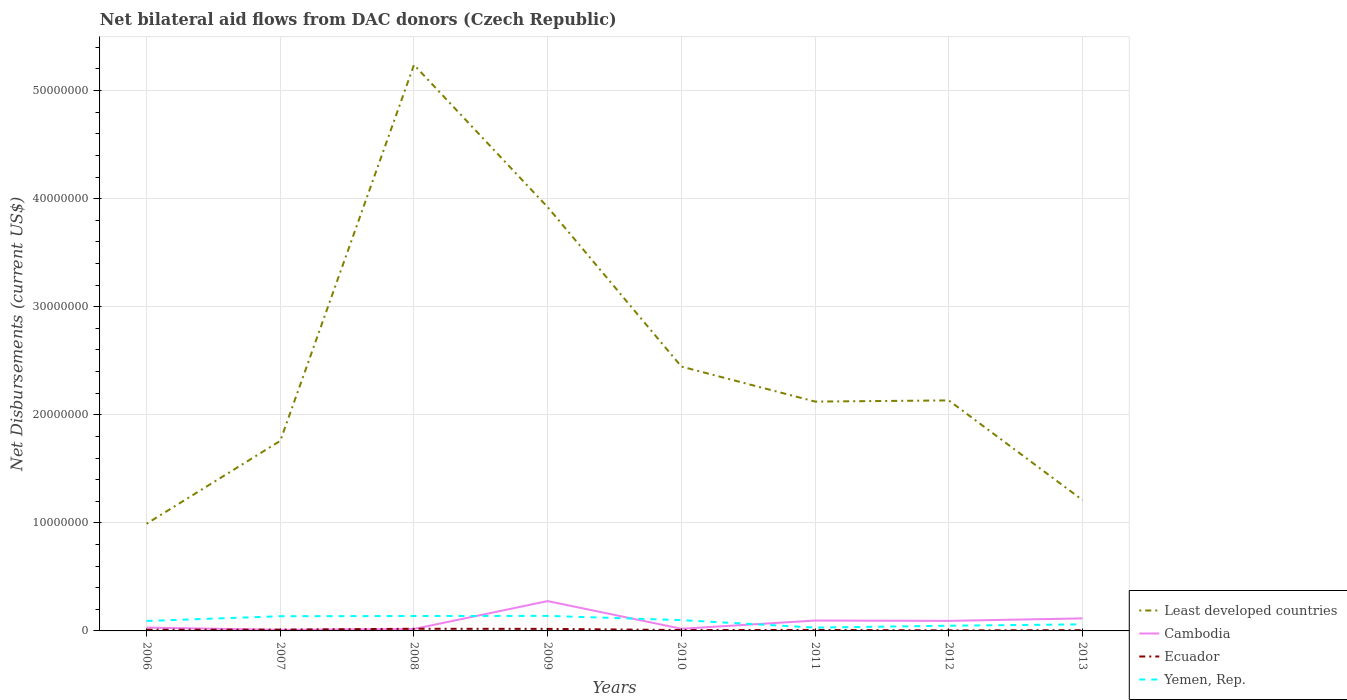How many different coloured lines are there?
Provide a short and direct response. 4. Does the line corresponding to Least developed countries intersect with the line corresponding to Yemen, Rep.?
Provide a short and direct response. No. Across all years, what is the maximum net bilateral aid flows in Ecuador?
Offer a terse response. 5.00e+04. In which year was the net bilateral aid flows in Cambodia maximum?
Offer a terse response. 2007. What is the total net bilateral aid flows in Ecuador in the graph?
Make the answer very short. 4.00e+04. What is the difference between the highest and the second highest net bilateral aid flows in Cambodia?
Make the answer very short. 2.66e+06. How many years are there in the graph?
Keep it short and to the point. 8. Are the values on the major ticks of Y-axis written in scientific E-notation?
Offer a very short reply. No. Does the graph contain any zero values?
Offer a very short reply. No. Does the graph contain grids?
Your response must be concise. Yes. How many legend labels are there?
Make the answer very short. 4. What is the title of the graph?
Ensure brevity in your answer.  Net bilateral aid flows from DAC donors (Czech Republic). What is the label or title of the X-axis?
Keep it short and to the point. Years. What is the label or title of the Y-axis?
Provide a succinct answer. Net Disbursements (current US$). What is the Net Disbursements (current US$) of Least developed countries in 2006?
Ensure brevity in your answer.  9.92e+06. What is the Net Disbursements (current US$) of Cambodia in 2006?
Ensure brevity in your answer.  3.10e+05. What is the Net Disbursements (current US$) of Yemen, Rep. in 2006?
Ensure brevity in your answer.  9.20e+05. What is the Net Disbursements (current US$) of Least developed countries in 2007?
Give a very brief answer. 1.76e+07. What is the Net Disbursements (current US$) of Cambodia in 2007?
Ensure brevity in your answer.  1.00e+05. What is the Net Disbursements (current US$) of Ecuador in 2007?
Provide a short and direct response. 1.20e+05. What is the Net Disbursements (current US$) of Yemen, Rep. in 2007?
Provide a succinct answer. 1.36e+06. What is the Net Disbursements (current US$) in Least developed countries in 2008?
Provide a succinct answer. 5.24e+07. What is the Net Disbursements (current US$) of Cambodia in 2008?
Offer a very short reply. 1.80e+05. What is the Net Disbursements (current US$) in Ecuador in 2008?
Offer a terse response. 2.00e+05. What is the Net Disbursements (current US$) of Yemen, Rep. in 2008?
Your response must be concise. 1.38e+06. What is the Net Disbursements (current US$) in Least developed countries in 2009?
Your answer should be compact. 3.92e+07. What is the Net Disbursements (current US$) of Cambodia in 2009?
Give a very brief answer. 2.76e+06. What is the Net Disbursements (current US$) of Ecuador in 2009?
Ensure brevity in your answer.  1.90e+05. What is the Net Disbursements (current US$) in Yemen, Rep. in 2009?
Give a very brief answer. 1.39e+06. What is the Net Disbursements (current US$) of Least developed countries in 2010?
Ensure brevity in your answer.  2.45e+07. What is the Net Disbursements (current US$) of Cambodia in 2010?
Your response must be concise. 2.00e+05. What is the Net Disbursements (current US$) of Ecuador in 2010?
Your response must be concise. 8.00e+04. What is the Net Disbursements (current US$) in Yemen, Rep. in 2010?
Provide a short and direct response. 1.00e+06. What is the Net Disbursements (current US$) of Least developed countries in 2011?
Your answer should be compact. 2.12e+07. What is the Net Disbursements (current US$) of Cambodia in 2011?
Your answer should be compact. 9.60e+05. What is the Net Disbursements (current US$) of Ecuador in 2011?
Provide a succinct answer. 9.00e+04. What is the Net Disbursements (current US$) in Yemen, Rep. in 2011?
Give a very brief answer. 3.10e+05. What is the Net Disbursements (current US$) in Least developed countries in 2012?
Keep it short and to the point. 2.13e+07. What is the Net Disbursements (current US$) of Cambodia in 2012?
Your answer should be very brief. 9.30e+05. What is the Net Disbursements (current US$) in Least developed countries in 2013?
Provide a short and direct response. 1.21e+07. What is the Net Disbursements (current US$) of Cambodia in 2013?
Ensure brevity in your answer.  1.16e+06. Across all years, what is the maximum Net Disbursements (current US$) in Least developed countries?
Keep it short and to the point. 5.24e+07. Across all years, what is the maximum Net Disbursements (current US$) in Cambodia?
Make the answer very short. 2.76e+06. Across all years, what is the maximum Net Disbursements (current US$) in Ecuador?
Make the answer very short. 2.00e+05. Across all years, what is the maximum Net Disbursements (current US$) in Yemen, Rep.?
Give a very brief answer. 1.39e+06. Across all years, what is the minimum Net Disbursements (current US$) in Least developed countries?
Offer a very short reply. 9.92e+06. Across all years, what is the minimum Net Disbursements (current US$) of Ecuador?
Offer a terse response. 5.00e+04. Across all years, what is the minimum Net Disbursements (current US$) of Yemen, Rep.?
Your answer should be very brief. 3.10e+05. What is the total Net Disbursements (current US$) of Least developed countries in the graph?
Your response must be concise. 1.98e+08. What is the total Net Disbursements (current US$) in Cambodia in the graph?
Your answer should be compact. 6.60e+06. What is the total Net Disbursements (current US$) in Ecuador in the graph?
Give a very brief answer. 9.10e+05. What is the total Net Disbursements (current US$) of Yemen, Rep. in the graph?
Provide a short and direct response. 7.45e+06. What is the difference between the Net Disbursements (current US$) in Least developed countries in 2006 and that in 2007?
Provide a short and direct response. -7.67e+06. What is the difference between the Net Disbursements (current US$) in Yemen, Rep. in 2006 and that in 2007?
Offer a very short reply. -4.40e+05. What is the difference between the Net Disbursements (current US$) in Least developed countries in 2006 and that in 2008?
Keep it short and to the point. -4.25e+07. What is the difference between the Net Disbursements (current US$) of Ecuador in 2006 and that in 2008?
Your answer should be very brief. -9.00e+04. What is the difference between the Net Disbursements (current US$) in Yemen, Rep. in 2006 and that in 2008?
Your answer should be very brief. -4.60e+05. What is the difference between the Net Disbursements (current US$) of Least developed countries in 2006 and that in 2009?
Ensure brevity in your answer.  -2.93e+07. What is the difference between the Net Disbursements (current US$) of Cambodia in 2006 and that in 2009?
Offer a terse response. -2.45e+06. What is the difference between the Net Disbursements (current US$) in Ecuador in 2006 and that in 2009?
Keep it short and to the point. -8.00e+04. What is the difference between the Net Disbursements (current US$) of Yemen, Rep. in 2006 and that in 2009?
Ensure brevity in your answer.  -4.70e+05. What is the difference between the Net Disbursements (current US$) of Least developed countries in 2006 and that in 2010?
Keep it short and to the point. -1.45e+07. What is the difference between the Net Disbursements (current US$) of Ecuador in 2006 and that in 2010?
Offer a very short reply. 3.00e+04. What is the difference between the Net Disbursements (current US$) in Yemen, Rep. in 2006 and that in 2010?
Make the answer very short. -8.00e+04. What is the difference between the Net Disbursements (current US$) of Least developed countries in 2006 and that in 2011?
Your response must be concise. -1.13e+07. What is the difference between the Net Disbursements (current US$) in Cambodia in 2006 and that in 2011?
Give a very brief answer. -6.50e+05. What is the difference between the Net Disbursements (current US$) of Ecuador in 2006 and that in 2011?
Your response must be concise. 2.00e+04. What is the difference between the Net Disbursements (current US$) in Yemen, Rep. in 2006 and that in 2011?
Offer a very short reply. 6.10e+05. What is the difference between the Net Disbursements (current US$) of Least developed countries in 2006 and that in 2012?
Your answer should be compact. -1.14e+07. What is the difference between the Net Disbursements (current US$) in Cambodia in 2006 and that in 2012?
Provide a succinct answer. -6.20e+05. What is the difference between the Net Disbursements (current US$) in Least developed countries in 2006 and that in 2013?
Provide a succinct answer. -2.19e+06. What is the difference between the Net Disbursements (current US$) in Cambodia in 2006 and that in 2013?
Make the answer very short. -8.50e+05. What is the difference between the Net Disbursements (current US$) in Ecuador in 2006 and that in 2013?
Ensure brevity in your answer.  4.00e+04. What is the difference between the Net Disbursements (current US$) of Least developed countries in 2007 and that in 2008?
Your response must be concise. -3.48e+07. What is the difference between the Net Disbursements (current US$) of Ecuador in 2007 and that in 2008?
Keep it short and to the point. -8.00e+04. What is the difference between the Net Disbursements (current US$) of Yemen, Rep. in 2007 and that in 2008?
Keep it short and to the point. -2.00e+04. What is the difference between the Net Disbursements (current US$) of Least developed countries in 2007 and that in 2009?
Your answer should be very brief. -2.16e+07. What is the difference between the Net Disbursements (current US$) of Cambodia in 2007 and that in 2009?
Your answer should be very brief. -2.66e+06. What is the difference between the Net Disbursements (current US$) of Yemen, Rep. in 2007 and that in 2009?
Offer a very short reply. -3.00e+04. What is the difference between the Net Disbursements (current US$) of Least developed countries in 2007 and that in 2010?
Make the answer very short. -6.87e+06. What is the difference between the Net Disbursements (current US$) in Cambodia in 2007 and that in 2010?
Your answer should be very brief. -1.00e+05. What is the difference between the Net Disbursements (current US$) in Yemen, Rep. in 2007 and that in 2010?
Keep it short and to the point. 3.60e+05. What is the difference between the Net Disbursements (current US$) in Least developed countries in 2007 and that in 2011?
Provide a succinct answer. -3.63e+06. What is the difference between the Net Disbursements (current US$) of Cambodia in 2007 and that in 2011?
Your answer should be compact. -8.60e+05. What is the difference between the Net Disbursements (current US$) in Yemen, Rep. in 2007 and that in 2011?
Offer a very short reply. 1.05e+06. What is the difference between the Net Disbursements (current US$) of Least developed countries in 2007 and that in 2012?
Offer a very short reply. -3.74e+06. What is the difference between the Net Disbursements (current US$) of Cambodia in 2007 and that in 2012?
Make the answer very short. -8.30e+05. What is the difference between the Net Disbursements (current US$) in Yemen, Rep. in 2007 and that in 2012?
Offer a terse response. 8.80e+05. What is the difference between the Net Disbursements (current US$) in Least developed countries in 2007 and that in 2013?
Offer a very short reply. 5.48e+06. What is the difference between the Net Disbursements (current US$) of Cambodia in 2007 and that in 2013?
Provide a succinct answer. -1.06e+06. What is the difference between the Net Disbursements (current US$) in Yemen, Rep. in 2007 and that in 2013?
Give a very brief answer. 7.50e+05. What is the difference between the Net Disbursements (current US$) of Least developed countries in 2008 and that in 2009?
Your response must be concise. 1.32e+07. What is the difference between the Net Disbursements (current US$) in Cambodia in 2008 and that in 2009?
Give a very brief answer. -2.58e+06. What is the difference between the Net Disbursements (current US$) in Ecuador in 2008 and that in 2009?
Ensure brevity in your answer.  10000. What is the difference between the Net Disbursements (current US$) of Yemen, Rep. in 2008 and that in 2009?
Keep it short and to the point. -10000. What is the difference between the Net Disbursements (current US$) of Least developed countries in 2008 and that in 2010?
Your answer should be compact. 2.79e+07. What is the difference between the Net Disbursements (current US$) of Ecuador in 2008 and that in 2010?
Your answer should be very brief. 1.20e+05. What is the difference between the Net Disbursements (current US$) of Yemen, Rep. in 2008 and that in 2010?
Offer a very short reply. 3.80e+05. What is the difference between the Net Disbursements (current US$) in Least developed countries in 2008 and that in 2011?
Offer a very short reply. 3.12e+07. What is the difference between the Net Disbursements (current US$) of Cambodia in 2008 and that in 2011?
Your response must be concise. -7.80e+05. What is the difference between the Net Disbursements (current US$) in Yemen, Rep. in 2008 and that in 2011?
Keep it short and to the point. 1.07e+06. What is the difference between the Net Disbursements (current US$) of Least developed countries in 2008 and that in 2012?
Offer a terse response. 3.10e+07. What is the difference between the Net Disbursements (current US$) of Cambodia in 2008 and that in 2012?
Provide a succinct answer. -7.50e+05. What is the difference between the Net Disbursements (current US$) of Ecuador in 2008 and that in 2012?
Offer a terse response. 1.50e+05. What is the difference between the Net Disbursements (current US$) in Least developed countries in 2008 and that in 2013?
Your answer should be very brief. 4.03e+07. What is the difference between the Net Disbursements (current US$) in Cambodia in 2008 and that in 2013?
Your answer should be compact. -9.80e+05. What is the difference between the Net Disbursements (current US$) in Ecuador in 2008 and that in 2013?
Make the answer very short. 1.30e+05. What is the difference between the Net Disbursements (current US$) in Yemen, Rep. in 2008 and that in 2013?
Offer a terse response. 7.70e+05. What is the difference between the Net Disbursements (current US$) of Least developed countries in 2009 and that in 2010?
Your answer should be very brief. 1.48e+07. What is the difference between the Net Disbursements (current US$) of Cambodia in 2009 and that in 2010?
Offer a terse response. 2.56e+06. What is the difference between the Net Disbursements (current US$) in Ecuador in 2009 and that in 2010?
Your response must be concise. 1.10e+05. What is the difference between the Net Disbursements (current US$) in Least developed countries in 2009 and that in 2011?
Offer a terse response. 1.80e+07. What is the difference between the Net Disbursements (current US$) of Cambodia in 2009 and that in 2011?
Offer a terse response. 1.80e+06. What is the difference between the Net Disbursements (current US$) of Yemen, Rep. in 2009 and that in 2011?
Your answer should be very brief. 1.08e+06. What is the difference between the Net Disbursements (current US$) in Least developed countries in 2009 and that in 2012?
Offer a terse response. 1.79e+07. What is the difference between the Net Disbursements (current US$) in Cambodia in 2009 and that in 2012?
Your answer should be very brief. 1.83e+06. What is the difference between the Net Disbursements (current US$) in Yemen, Rep. in 2009 and that in 2012?
Offer a very short reply. 9.10e+05. What is the difference between the Net Disbursements (current US$) in Least developed countries in 2009 and that in 2013?
Offer a terse response. 2.71e+07. What is the difference between the Net Disbursements (current US$) of Cambodia in 2009 and that in 2013?
Your answer should be very brief. 1.60e+06. What is the difference between the Net Disbursements (current US$) of Yemen, Rep. in 2009 and that in 2013?
Provide a succinct answer. 7.80e+05. What is the difference between the Net Disbursements (current US$) of Least developed countries in 2010 and that in 2011?
Offer a terse response. 3.24e+06. What is the difference between the Net Disbursements (current US$) of Cambodia in 2010 and that in 2011?
Make the answer very short. -7.60e+05. What is the difference between the Net Disbursements (current US$) in Yemen, Rep. in 2010 and that in 2011?
Your answer should be very brief. 6.90e+05. What is the difference between the Net Disbursements (current US$) in Least developed countries in 2010 and that in 2012?
Ensure brevity in your answer.  3.13e+06. What is the difference between the Net Disbursements (current US$) in Cambodia in 2010 and that in 2012?
Provide a short and direct response. -7.30e+05. What is the difference between the Net Disbursements (current US$) of Yemen, Rep. in 2010 and that in 2012?
Provide a short and direct response. 5.20e+05. What is the difference between the Net Disbursements (current US$) in Least developed countries in 2010 and that in 2013?
Give a very brief answer. 1.24e+07. What is the difference between the Net Disbursements (current US$) of Cambodia in 2010 and that in 2013?
Make the answer very short. -9.60e+05. What is the difference between the Net Disbursements (current US$) of Ecuador in 2010 and that in 2013?
Your answer should be very brief. 10000. What is the difference between the Net Disbursements (current US$) of Yemen, Rep. in 2010 and that in 2013?
Ensure brevity in your answer.  3.90e+05. What is the difference between the Net Disbursements (current US$) in Ecuador in 2011 and that in 2012?
Give a very brief answer. 4.00e+04. What is the difference between the Net Disbursements (current US$) in Least developed countries in 2011 and that in 2013?
Offer a very short reply. 9.11e+06. What is the difference between the Net Disbursements (current US$) of Ecuador in 2011 and that in 2013?
Make the answer very short. 2.00e+04. What is the difference between the Net Disbursements (current US$) in Least developed countries in 2012 and that in 2013?
Provide a short and direct response. 9.22e+06. What is the difference between the Net Disbursements (current US$) of Cambodia in 2012 and that in 2013?
Your answer should be very brief. -2.30e+05. What is the difference between the Net Disbursements (current US$) of Least developed countries in 2006 and the Net Disbursements (current US$) of Cambodia in 2007?
Your response must be concise. 9.82e+06. What is the difference between the Net Disbursements (current US$) of Least developed countries in 2006 and the Net Disbursements (current US$) of Ecuador in 2007?
Your answer should be very brief. 9.80e+06. What is the difference between the Net Disbursements (current US$) in Least developed countries in 2006 and the Net Disbursements (current US$) in Yemen, Rep. in 2007?
Make the answer very short. 8.56e+06. What is the difference between the Net Disbursements (current US$) in Cambodia in 2006 and the Net Disbursements (current US$) in Yemen, Rep. in 2007?
Keep it short and to the point. -1.05e+06. What is the difference between the Net Disbursements (current US$) of Ecuador in 2006 and the Net Disbursements (current US$) of Yemen, Rep. in 2007?
Ensure brevity in your answer.  -1.25e+06. What is the difference between the Net Disbursements (current US$) in Least developed countries in 2006 and the Net Disbursements (current US$) in Cambodia in 2008?
Make the answer very short. 9.74e+06. What is the difference between the Net Disbursements (current US$) of Least developed countries in 2006 and the Net Disbursements (current US$) of Ecuador in 2008?
Ensure brevity in your answer.  9.72e+06. What is the difference between the Net Disbursements (current US$) of Least developed countries in 2006 and the Net Disbursements (current US$) of Yemen, Rep. in 2008?
Ensure brevity in your answer.  8.54e+06. What is the difference between the Net Disbursements (current US$) in Cambodia in 2006 and the Net Disbursements (current US$) in Yemen, Rep. in 2008?
Ensure brevity in your answer.  -1.07e+06. What is the difference between the Net Disbursements (current US$) in Ecuador in 2006 and the Net Disbursements (current US$) in Yemen, Rep. in 2008?
Offer a terse response. -1.27e+06. What is the difference between the Net Disbursements (current US$) in Least developed countries in 2006 and the Net Disbursements (current US$) in Cambodia in 2009?
Offer a terse response. 7.16e+06. What is the difference between the Net Disbursements (current US$) of Least developed countries in 2006 and the Net Disbursements (current US$) of Ecuador in 2009?
Your answer should be very brief. 9.73e+06. What is the difference between the Net Disbursements (current US$) in Least developed countries in 2006 and the Net Disbursements (current US$) in Yemen, Rep. in 2009?
Your response must be concise. 8.53e+06. What is the difference between the Net Disbursements (current US$) in Cambodia in 2006 and the Net Disbursements (current US$) in Ecuador in 2009?
Give a very brief answer. 1.20e+05. What is the difference between the Net Disbursements (current US$) of Cambodia in 2006 and the Net Disbursements (current US$) of Yemen, Rep. in 2009?
Offer a very short reply. -1.08e+06. What is the difference between the Net Disbursements (current US$) in Ecuador in 2006 and the Net Disbursements (current US$) in Yemen, Rep. in 2009?
Provide a short and direct response. -1.28e+06. What is the difference between the Net Disbursements (current US$) of Least developed countries in 2006 and the Net Disbursements (current US$) of Cambodia in 2010?
Provide a succinct answer. 9.72e+06. What is the difference between the Net Disbursements (current US$) in Least developed countries in 2006 and the Net Disbursements (current US$) in Ecuador in 2010?
Offer a terse response. 9.84e+06. What is the difference between the Net Disbursements (current US$) of Least developed countries in 2006 and the Net Disbursements (current US$) of Yemen, Rep. in 2010?
Your answer should be very brief. 8.92e+06. What is the difference between the Net Disbursements (current US$) in Cambodia in 2006 and the Net Disbursements (current US$) in Ecuador in 2010?
Your answer should be compact. 2.30e+05. What is the difference between the Net Disbursements (current US$) in Cambodia in 2006 and the Net Disbursements (current US$) in Yemen, Rep. in 2010?
Your answer should be compact. -6.90e+05. What is the difference between the Net Disbursements (current US$) in Ecuador in 2006 and the Net Disbursements (current US$) in Yemen, Rep. in 2010?
Ensure brevity in your answer.  -8.90e+05. What is the difference between the Net Disbursements (current US$) in Least developed countries in 2006 and the Net Disbursements (current US$) in Cambodia in 2011?
Make the answer very short. 8.96e+06. What is the difference between the Net Disbursements (current US$) in Least developed countries in 2006 and the Net Disbursements (current US$) in Ecuador in 2011?
Provide a succinct answer. 9.83e+06. What is the difference between the Net Disbursements (current US$) in Least developed countries in 2006 and the Net Disbursements (current US$) in Yemen, Rep. in 2011?
Your response must be concise. 9.61e+06. What is the difference between the Net Disbursements (current US$) of Cambodia in 2006 and the Net Disbursements (current US$) of Yemen, Rep. in 2011?
Your response must be concise. 0. What is the difference between the Net Disbursements (current US$) of Least developed countries in 2006 and the Net Disbursements (current US$) of Cambodia in 2012?
Offer a very short reply. 8.99e+06. What is the difference between the Net Disbursements (current US$) of Least developed countries in 2006 and the Net Disbursements (current US$) of Ecuador in 2012?
Give a very brief answer. 9.87e+06. What is the difference between the Net Disbursements (current US$) of Least developed countries in 2006 and the Net Disbursements (current US$) of Yemen, Rep. in 2012?
Ensure brevity in your answer.  9.44e+06. What is the difference between the Net Disbursements (current US$) of Cambodia in 2006 and the Net Disbursements (current US$) of Yemen, Rep. in 2012?
Your answer should be very brief. -1.70e+05. What is the difference between the Net Disbursements (current US$) of Ecuador in 2006 and the Net Disbursements (current US$) of Yemen, Rep. in 2012?
Your answer should be compact. -3.70e+05. What is the difference between the Net Disbursements (current US$) in Least developed countries in 2006 and the Net Disbursements (current US$) in Cambodia in 2013?
Provide a succinct answer. 8.76e+06. What is the difference between the Net Disbursements (current US$) in Least developed countries in 2006 and the Net Disbursements (current US$) in Ecuador in 2013?
Keep it short and to the point. 9.85e+06. What is the difference between the Net Disbursements (current US$) of Least developed countries in 2006 and the Net Disbursements (current US$) of Yemen, Rep. in 2013?
Offer a very short reply. 9.31e+06. What is the difference between the Net Disbursements (current US$) in Cambodia in 2006 and the Net Disbursements (current US$) in Ecuador in 2013?
Provide a short and direct response. 2.40e+05. What is the difference between the Net Disbursements (current US$) of Ecuador in 2006 and the Net Disbursements (current US$) of Yemen, Rep. in 2013?
Offer a terse response. -5.00e+05. What is the difference between the Net Disbursements (current US$) in Least developed countries in 2007 and the Net Disbursements (current US$) in Cambodia in 2008?
Provide a succinct answer. 1.74e+07. What is the difference between the Net Disbursements (current US$) of Least developed countries in 2007 and the Net Disbursements (current US$) of Ecuador in 2008?
Ensure brevity in your answer.  1.74e+07. What is the difference between the Net Disbursements (current US$) in Least developed countries in 2007 and the Net Disbursements (current US$) in Yemen, Rep. in 2008?
Your response must be concise. 1.62e+07. What is the difference between the Net Disbursements (current US$) of Cambodia in 2007 and the Net Disbursements (current US$) of Yemen, Rep. in 2008?
Your answer should be compact. -1.28e+06. What is the difference between the Net Disbursements (current US$) in Ecuador in 2007 and the Net Disbursements (current US$) in Yemen, Rep. in 2008?
Offer a terse response. -1.26e+06. What is the difference between the Net Disbursements (current US$) of Least developed countries in 2007 and the Net Disbursements (current US$) of Cambodia in 2009?
Provide a succinct answer. 1.48e+07. What is the difference between the Net Disbursements (current US$) of Least developed countries in 2007 and the Net Disbursements (current US$) of Ecuador in 2009?
Keep it short and to the point. 1.74e+07. What is the difference between the Net Disbursements (current US$) of Least developed countries in 2007 and the Net Disbursements (current US$) of Yemen, Rep. in 2009?
Your answer should be very brief. 1.62e+07. What is the difference between the Net Disbursements (current US$) of Cambodia in 2007 and the Net Disbursements (current US$) of Yemen, Rep. in 2009?
Offer a terse response. -1.29e+06. What is the difference between the Net Disbursements (current US$) of Ecuador in 2007 and the Net Disbursements (current US$) of Yemen, Rep. in 2009?
Offer a very short reply. -1.27e+06. What is the difference between the Net Disbursements (current US$) of Least developed countries in 2007 and the Net Disbursements (current US$) of Cambodia in 2010?
Offer a very short reply. 1.74e+07. What is the difference between the Net Disbursements (current US$) of Least developed countries in 2007 and the Net Disbursements (current US$) of Ecuador in 2010?
Your response must be concise. 1.75e+07. What is the difference between the Net Disbursements (current US$) in Least developed countries in 2007 and the Net Disbursements (current US$) in Yemen, Rep. in 2010?
Give a very brief answer. 1.66e+07. What is the difference between the Net Disbursements (current US$) of Cambodia in 2007 and the Net Disbursements (current US$) of Ecuador in 2010?
Keep it short and to the point. 2.00e+04. What is the difference between the Net Disbursements (current US$) in Cambodia in 2007 and the Net Disbursements (current US$) in Yemen, Rep. in 2010?
Ensure brevity in your answer.  -9.00e+05. What is the difference between the Net Disbursements (current US$) in Ecuador in 2007 and the Net Disbursements (current US$) in Yemen, Rep. in 2010?
Your answer should be compact. -8.80e+05. What is the difference between the Net Disbursements (current US$) of Least developed countries in 2007 and the Net Disbursements (current US$) of Cambodia in 2011?
Your answer should be very brief. 1.66e+07. What is the difference between the Net Disbursements (current US$) in Least developed countries in 2007 and the Net Disbursements (current US$) in Ecuador in 2011?
Your answer should be very brief. 1.75e+07. What is the difference between the Net Disbursements (current US$) of Least developed countries in 2007 and the Net Disbursements (current US$) of Yemen, Rep. in 2011?
Your response must be concise. 1.73e+07. What is the difference between the Net Disbursements (current US$) in Cambodia in 2007 and the Net Disbursements (current US$) in Ecuador in 2011?
Offer a very short reply. 10000. What is the difference between the Net Disbursements (current US$) of Ecuador in 2007 and the Net Disbursements (current US$) of Yemen, Rep. in 2011?
Offer a very short reply. -1.90e+05. What is the difference between the Net Disbursements (current US$) in Least developed countries in 2007 and the Net Disbursements (current US$) in Cambodia in 2012?
Ensure brevity in your answer.  1.67e+07. What is the difference between the Net Disbursements (current US$) of Least developed countries in 2007 and the Net Disbursements (current US$) of Ecuador in 2012?
Give a very brief answer. 1.75e+07. What is the difference between the Net Disbursements (current US$) in Least developed countries in 2007 and the Net Disbursements (current US$) in Yemen, Rep. in 2012?
Your answer should be very brief. 1.71e+07. What is the difference between the Net Disbursements (current US$) of Cambodia in 2007 and the Net Disbursements (current US$) of Yemen, Rep. in 2012?
Make the answer very short. -3.80e+05. What is the difference between the Net Disbursements (current US$) of Ecuador in 2007 and the Net Disbursements (current US$) of Yemen, Rep. in 2012?
Ensure brevity in your answer.  -3.60e+05. What is the difference between the Net Disbursements (current US$) in Least developed countries in 2007 and the Net Disbursements (current US$) in Cambodia in 2013?
Provide a succinct answer. 1.64e+07. What is the difference between the Net Disbursements (current US$) of Least developed countries in 2007 and the Net Disbursements (current US$) of Ecuador in 2013?
Give a very brief answer. 1.75e+07. What is the difference between the Net Disbursements (current US$) of Least developed countries in 2007 and the Net Disbursements (current US$) of Yemen, Rep. in 2013?
Provide a short and direct response. 1.70e+07. What is the difference between the Net Disbursements (current US$) of Cambodia in 2007 and the Net Disbursements (current US$) of Yemen, Rep. in 2013?
Your response must be concise. -5.10e+05. What is the difference between the Net Disbursements (current US$) in Ecuador in 2007 and the Net Disbursements (current US$) in Yemen, Rep. in 2013?
Your answer should be very brief. -4.90e+05. What is the difference between the Net Disbursements (current US$) of Least developed countries in 2008 and the Net Disbursements (current US$) of Cambodia in 2009?
Your answer should be compact. 4.96e+07. What is the difference between the Net Disbursements (current US$) of Least developed countries in 2008 and the Net Disbursements (current US$) of Ecuador in 2009?
Your response must be concise. 5.22e+07. What is the difference between the Net Disbursements (current US$) of Least developed countries in 2008 and the Net Disbursements (current US$) of Yemen, Rep. in 2009?
Give a very brief answer. 5.10e+07. What is the difference between the Net Disbursements (current US$) in Cambodia in 2008 and the Net Disbursements (current US$) in Ecuador in 2009?
Provide a succinct answer. -10000. What is the difference between the Net Disbursements (current US$) in Cambodia in 2008 and the Net Disbursements (current US$) in Yemen, Rep. in 2009?
Your answer should be very brief. -1.21e+06. What is the difference between the Net Disbursements (current US$) in Ecuador in 2008 and the Net Disbursements (current US$) in Yemen, Rep. in 2009?
Your answer should be very brief. -1.19e+06. What is the difference between the Net Disbursements (current US$) of Least developed countries in 2008 and the Net Disbursements (current US$) of Cambodia in 2010?
Make the answer very short. 5.22e+07. What is the difference between the Net Disbursements (current US$) of Least developed countries in 2008 and the Net Disbursements (current US$) of Ecuador in 2010?
Give a very brief answer. 5.23e+07. What is the difference between the Net Disbursements (current US$) of Least developed countries in 2008 and the Net Disbursements (current US$) of Yemen, Rep. in 2010?
Keep it short and to the point. 5.14e+07. What is the difference between the Net Disbursements (current US$) in Cambodia in 2008 and the Net Disbursements (current US$) in Ecuador in 2010?
Give a very brief answer. 1.00e+05. What is the difference between the Net Disbursements (current US$) in Cambodia in 2008 and the Net Disbursements (current US$) in Yemen, Rep. in 2010?
Offer a terse response. -8.20e+05. What is the difference between the Net Disbursements (current US$) in Ecuador in 2008 and the Net Disbursements (current US$) in Yemen, Rep. in 2010?
Your response must be concise. -8.00e+05. What is the difference between the Net Disbursements (current US$) of Least developed countries in 2008 and the Net Disbursements (current US$) of Cambodia in 2011?
Provide a succinct answer. 5.14e+07. What is the difference between the Net Disbursements (current US$) of Least developed countries in 2008 and the Net Disbursements (current US$) of Ecuador in 2011?
Keep it short and to the point. 5.23e+07. What is the difference between the Net Disbursements (current US$) of Least developed countries in 2008 and the Net Disbursements (current US$) of Yemen, Rep. in 2011?
Make the answer very short. 5.21e+07. What is the difference between the Net Disbursements (current US$) of Least developed countries in 2008 and the Net Disbursements (current US$) of Cambodia in 2012?
Provide a succinct answer. 5.14e+07. What is the difference between the Net Disbursements (current US$) of Least developed countries in 2008 and the Net Disbursements (current US$) of Ecuador in 2012?
Ensure brevity in your answer.  5.23e+07. What is the difference between the Net Disbursements (current US$) of Least developed countries in 2008 and the Net Disbursements (current US$) of Yemen, Rep. in 2012?
Provide a short and direct response. 5.19e+07. What is the difference between the Net Disbursements (current US$) in Cambodia in 2008 and the Net Disbursements (current US$) in Ecuador in 2012?
Give a very brief answer. 1.30e+05. What is the difference between the Net Disbursements (current US$) of Cambodia in 2008 and the Net Disbursements (current US$) of Yemen, Rep. in 2012?
Give a very brief answer. -3.00e+05. What is the difference between the Net Disbursements (current US$) of Ecuador in 2008 and the Net Disbursements (current US$) of Yemen, Rep. in 2012?
Offer a terse response. -2.80e+05. What is the difference between the Net Disbursements (current US$) in Least developed countries in 2008 and the Net Disbursements (current US$) in Cambodia in 2013?
Your response must be concise. 5.12e+07. What is the difference between the Net Disbursements (current US$) in Least developed countries in 2008 and the Net Disbursements (current US$) in Ecuador in 2013?
Offer a very short reply. 5.23e+07. What is the difference between the Net Disbursements (current US$) in Least developed countries in 2008 and the Net Disbursements (current US$) in Yemen, Rep. in 2013?
Provide a succinct answer. 5.18e+07. What is the difference between the Net Disbursements (current US$) of Cambodia in 2008 and the Net Disbursements (current US$) of Yemen, Rep. in 2013?
Your response must be concise. -4.30e+05. What is the difference between the Net Disbursements (current US$) of Ecuador in 2008 and the Net Disbursements (current US$) of Yemen, Rep. in 2013?
Give a very brief answer. -4.10e+05. What is the difference between the Net Disbursements (current US$) of Least developed countries in 2009 and the Net Disbursements (current US$) of Cambodia in 2010?
Keep it short and to the point. 3.90e+07. What is the difference between the Net Disbursements (current US$) in Least developed countries in 2009 and the Net Disbursements (current US$) in Ecuador in 2010?
Your answer should be compact. 3.91e+07. What is the difference between the Net Disbursements (current US$) of Least developed countries in 2009 and the Net Disbursements (current US$) of Yemen, Rep. in 2010?
Make the answer very short. 3.82e+07. What is the difference between the Net Disbursements (current US$) of Cambodia in 2009 and the Net Disbursements (current US$) of Ecuador in 2010?
Your answer should be very brief. 2.68e+06. What is the difference between the Net Disbursements (current US$) of Cambodia in 2009 and the Net Disbursements (current US$) of Yemen, Rep. in 2010?
Give a very brief answer. 1.76e+06. What is the difference between the Net Disbursements (current US$) of Ecuador in 2009 and the Net Disbursements (current US$) of Yemen, Rep. in 2010?
Your answer should be compact. -8.10e+05. What is the difference between the Net Disbursements (current US$) of Least developed countries in 2009 and the Net Disbursements (current US$) of Cambodia in 2011?
Provide a succinct answer. 3.82e+07. What is the difference between the Net Disbursements (current US$) of Least developed countries in 2009 and the Net Disbursements (current US$) of Ecuador in 2011?
Offer a very short reply. 3.91e+07. What is the difference between the Net Disbursements (current US$) in Least developed countries in 2009 and the Net Disbursements (current US$) in Yemen, Rep. in 2011?
Provide a short and direct response. 3.89e+07. What is the difference between the Net Disbursements (current US$) of Cambodia in 2009 and the Net Disbursements (current US$) of Ecuador in 2011?
Your answer should be very brief. 2.67e+06. What is the difference between the Net Disbursements (current US$) of Cambodia in 2009 and the Net Disbursements (current US$) of Yemen, Rep. in 2011?
Your response must be concise. 2.45e+06. What is the difference between the Net Disbursements (current US$) in Ecuador in 2009 and the Net Disbursements (current US$) in Yemen, Rep. in 2011?
Your response must be concise. -1.20e+05. What is the difference between the Net Disbursements (current US$) of Least developed countries in 2009 and the Net Disbursements (current US$) of Cambodia in 2012?
Your answer should be compact. 3.83e+07. What is the difference between the Net Disbursements (current US$) in Least developed countries in 2009 and the Net Disbursements (current US$) in Ecuador in 2012?
Your answer should be very brief. 3.92e+07. What is the difference between the Net Disbursements (current US$) of Least developed countries in 2009 and the Net Disbursements (current US$) of Yemen, Rep. in 2012?
Your response must be concise. 3.87e+07. What is the difference between the Net Disbursements (current US$) in Cambodia in 2009 and the Net Disbursements (current US$) in Ecuador in 2012?
Offer a terse response. 2.71e+06. What is the difference between the Net Disbursements (current US$) in Cambodia in 2009 and the Net Disbursements (current US$) in Yemen, Rep. in 2012?
Keep it short and to the point. 2.28e+06. What is the difference between the Net Disbursements (current US$) in Least developed countries in 2009 and the Net Disbursements (current US$) in Cambodia in 2013?
Your answer should be compact. 3.80e+07. What is the difference between the Net Disbursements (current US$) of Least developed countries in 2009 and the Net Disbursements (current US$) of Ecuador in 2013?
Make the answer very short. 3.91e+07. What is the difference between the Net Disbursements (current US$) in Least developed countries in 2009 and the Net Disbursements (current US$) in Yemen, Rep. in 2013?
Keep it short and to the point. 3.86e+07. What is the difference between the Net Disbursements (current US$) of Cambodia in 2009 and the Net Disbursements (current US$) of Ecuador in 2013?
Provide a short and direct response. 2.69e+06. What is the difference between the Net Disbursements (current US$) in Cambodia in 2009 and the Net Disbursements (current US$) in Yemen, Rep. in 2013?
Give a very brief answer. 2.15e+06. What is the difference between the Net Disbursements (current US$) in Ecuador in 2009 and the Net Disbursements (current US$) in Yemen, Rep. in 2013?
Offer a very short reply. -4.20e+05. What is the difference between the Net Disbursements (current US$) in Least developed countries in 2010 and the Net Disbursements (current US$) in Cambodia in 2011?
Your answer should be compact. 2.35e+07. What is the difference between the Net Disbursements (current US$) in Least developed countries in 2010 and the Net Disbursements (current US$) in Ecuador in 2011?
Keep it short and to the point. 2.44e+07. What is the difference between the Net Disbursements (current US$) of Least developed countries in 2010 and the Net Disbursements (current US$) of Yemen, Rep. in 2011?
Your answer should be very brief. 2.42e+07. What is the difference between the Net Disbursements (current US$) in Cambodia in 2010 and the Net Disbursements (current US$) in Ecuador in 2011?
Provide a succinct answer. 1.10e+05. What is the difference between the Net Disbursements (current US$) of Cambodia in 2010 and the Net Disbursements (current US$) of Yemen, Rep. in 2011?
Provide a short and direct response. -1.10e+05. What is the difference between the Net Disbursements (current US$) in Ecuador in 2010 and the Net Disbursements (current US$) in Yemen, Rep. in 2011?
Keep it short and to the point. -2.30e+05. What is the difference between the Net Disbursements (current US$) in Least developed countries in 2010 and the Net Disbursements (current US$) in Cambodia in 2012?
Your response must be concise. 2.35e+07. What is the difference between the Net Disbursements (current US$) in Least developed countries in 2010 and the Net Disbursements (current US$) in Ecuador in 2012?
Offer a terse response. 2.44e+07. What is the difference between the Net Disbursements (current US$) of Least developed countries in 2010 and the Net Disbursements (current US$) of Yemen, Rep. in 2012?
Your answer should be very brief. 2.40e+07. What is the difference between the Net Disbursements (current US$) in Cambodia in 2010 and the Net Disbursements (current US$) in Yemen, Rep. in 2012?
Provide a short and direct response. -2.80e+05. What is the difference between the Net Disbursements (current US$) of Ecuador in 2010 and the Net Disbursements (current US$) of Yemen, Rep. in 2012?
Ensure brevity in your answer.  -4.00e+05. What is the difference between the Net Disbursements (current US$) in Least developed countries in 2010 and the Net Disbursements (current US$) in Cambodia in 2013?
Your answer should be very brief. 2.33e+07. What is the difference between the Net Disbursements (current US$) in Least developed countries in 2010 and the Net Disbursements (current US$) in Ecuador in 2013?
Your answer should be very brief. 2.44e+07. What is the difference between the Net Disbursements (current US$) of Least developed countries in 2010 and the Net Disbursements (current US$) of Yemen, Rep. in 2013?
Give a very brief answer. 2.38e+07. What is the difference between the Net Disbursements (current US$) of Cambodia in 2010 and the Net Disbursements (current US$) of Ecuador in 2013?
Keep it short and to the point. 1.30e+05. What is the difference between the Net Disbursements (current US$) of Cambodia in 2010 and the Net Disbursements (current US$) of Yemen, Rep. in 2013?
Give a very brief answer. -4.10e+05. What is the difference between the Net Disbursements (current US$) in Ecuador in 2010 and the Net Disbursements (current US$) in Yemen, Rep. in 2013?
Make the answer very short. -5.30e+05. What is the difference between the Net Disbursements (current US$) in Least developed countries in 2011 and the Net Disbursements (current US$) in Cambodia in 2012?
Ensure brevity in your answer.  2.03e+07. What is the difference between the Net Disbursements (current US$) in Least developed countries in 2011 and the Net Disbursements (current US$) in Ecuador in 2012?
Offer a very short reply. 2.12e+07. What is the difference between the Net Disbursements (current US$) of Least developed countries in 2011 and the Net Disbursements (current US$) of Yemen, Rep. in 2012?
Ensure brevity in your answer.  2.07e+07. What is the difference between the Net Disbursements (current US$) of Cambodia in 2011 and the Net Disbursements (current US$) of Ecuador in 2012?
Your response must be concise. 9.10e+05. What is the difference between the Net Disbursements (current US$) in Ecuador in 2011 and the Net Disbursements (current US$) in Yemen, Rep. in 2012?
Ensure brevity in your answer.  -3.90e+05. What is the difference between the Net Disbursements (current US$) of Least developed countries in 2011 and the Net Disbursements (current US$) of Cambodia in 2013?
Your answer should be compact. 2.01e+07. What is the difference between the Net Disbursements (current US$) of Least developed countries in 2011 and the Net Disbursements (current US$) of Ecuador in 2013?
Provide a succinct answer. 2.12e+07. What is the difference between the Net Disbursements (current US$) in Least developed countries in 2011 and the Net Disbursements (current US$) in Yemen, Rep. in 2013?
Your answer should be very brief. 2.06e+07. What is the difference between the Net Disbursements (current US$) in Cambodia in 2011 and the Net Disbursements (current US$) in Ecuador in 2013?
Your response must be concise. 8.90e+05. What is the difference between the Net Disbursements (current US$) of Ecuador in 2011 and the Net Disbursements (current US$) of Yemen, Rep. in 2013?
Your answer should be very brief. -5.20e+05. What is the difference between the Net Disbursements (current US$) in Least developed countries in 2012 and the Net Disbursements (current US$) in Cambodia in 2013?
Provide a succinct answer. 2.02e+07. What is the difference between the Net Disbursements (current US$) in Least developed countries in 2012 and the Net Disbursements (current US$) in Ecuador in 2013?
Offer a very short reply. 2.13e+07. What is the difference between the Net Disbursements (current US$) of Least developed countries in 2012 and the Net Disbursements (current US$) of Yemen, Rep. in 2013?
Your response must be concise. 2.07e+07. What is the difference between the Net Disbursements (current US$) of Cambodia in 2012 and the Net Disbursements (current US$) of Ecuador in 2013?
Offer a very short reply. 8.60e+05. What is the difference between the Net Disbursements (current US$) in Cambodia in 2012 and the Net Disbursements (current US$) in Yemen, Rep. in 2013?
Provide a short and direct response. 3.20e+05. What is the difference between the Net Disbursements (current US$) of Ecuador in 2012 and the Net Disbursements (current US$) of Yemen, Rep. in 2013?
Your answer should be very brief. -5.60e+05. What is the average Net Disbursements (current US$) of Least developed countries per year?
Give a very brief answer. 2.48e+07. What is the average Net Disbursements (current US$) in Cambodia per year?
Give a very brief answer. 8.25e+05. What is the average Net Disbursements (current US$) in Ecuador per year?
Offer a very short reply. 1.14e+05. What is the average Net Disbursements (current US$) in Yemen, Rep. per year?
Your answer should be compact. 9.31e+05. In the year 2006, what is the difference between the Net Disbursements (current US$) in Least developed countries and Net Disbursements (current US$) in Cambodia?
Your response must be concise. 9.61e+06. In the year 2006, what is the difference between the Net Disbursements (current US$) in Least developed countries and Net Disbursements (current US$) in Ecuador?
Offer a very short reply. 9.81e+06. In the year 2006, what is the difference between the Net Disbursements (current US$) in Least developed countries and Net Disbursements (current US$) in Yemen, Rep.?
Ensure brevity in your answer.  9.00e+06. In the year 2006, what is the difference between the Net Disbursements (current US$) of Cambodia and Net Disbursements (current US$) of Ecuador?
Your answer should be compact. 2.00e+05. In the year 2006, what is the difference between the Net Disbursements (current US$) of Cambodia and Net Disbursements (current US$) of Yemen, Rep.?
Your answer should be compact. -6.10e+05. In the year 2006, what is the difference between the Net Disbursements (current US$) in Ecuador and Net Disbursements (current US$) in Yemen, Rep.?
Your answer should be compact. -8.10e+05. In the year 2007, what is the difference between the Net Disbursements (current US$) in Least developed countries and Net Disbursements (current US$) in Cambodia?
Ensure brevity in your answer.  1.75e+07. In the year 2007, what is the difference between the Net Disbursements (current US$) in Least developed countries and Net Disbursements (current US$) in Ecuador?
Your response must be concise. 1.75e+07. In the year 2007, what is the difference between the Net Disbursements (current US$) in Least developed countries and Net Disbursements (current US$) in Yemen, Rep.?
Give a very brief answer. 1.62e+07. In the year 2007, what is the difference between the Net Disbursements (current US$) of Cambodia and Net Disbursements (current US$) of Yemen, Rep.?
Make the answer very short. -1.26e+06. In the year 2007, what is the difference between the Net Disbursements (current US$) of Ecuador and Net Disbursements (current US$) of Yemen, Rep.?
Provide a succinct answer. -1.24e+06. In the year 2008, what is the difference between the Net Disbursements (current US$) of Least developed countries and Net Disbursements (current US$) of Cambodia?
Provide a succinct answer. 5.22e+07. In the year 2008, what is the difference between the Net Disbursements (current US$) in Least developed countries and Net Disbursements (current US$) in Ecuador?
Provide a succinct answer. 5.22e+07. In the year 2008, what is the difference between the Net Disbursements (current US$) in Least developed countries and Net Disbursements (current US$) in Yemen, Rep.?
Offer a terse response. 5.10e+07. In the year 2008, what is the difference between the Net Disbursements (current US$) in Cambodia and Net Disbursements (current US$) in Ecuador?
Provide a short and direct response. -2.00e+04. In the year 2008, what is the difference between the Net Disbursements (current US$) of Cambodia and Net Disbursements (current US$) of Yemen, Rep.?
Keep it short and to the point. -1.20e+06. In the year 2008, what is the difference between the Net Disbursements (current US$) of Ecuador and Net Disbursements (current US$) of Yemen, Rep.?
Ensure brevity in your answer.  -1.18e+06. In the year 2009, what is the difference between the Net Disbursements (current US$) in Least developed countries and Net Disbursements (current US$) in Cambodia?
Offer a terse response. 3.64e+07. In the year 2009, what is the difference between the Net Disbursements (current US$) in Least developed countries and Net Disbursements (current US$) in Ecuador?
Your response must be concise. 3.90e+07. In the year 2009, what is the difference between the Net Disbursements (current US$) in Least developed countries and Net Disbursements (current US$) in Yemen, Rep.?
Provide a succinct answer. 3.78e+07. In the year 2009, what is the difference between the Net Disbursements (current US$) of Cambodia and Net Disbursements (current US$) of Ecuador?
Keep it short and to the point. 2.57e+06. In the year 2009, what is the difference between the Net Disbursements (current US$) in Cambodia and Net Disbursements (current US$) in Yemen, Rep.?
Provide a succinct answer. 1.37e+06. In the year 2009, what is the difference between the Net Disbursements (current US$) in Ecuador and Net Disbursements (current US$) in Yemen, Rep.?
Ensure brevity in your answer.  -1.20e+06. In the year 2010, what is the difference between the Net Disbursements (current US$) of Least developed countries and Net Disbursements (current US$) of Cambodia?
Offer a terse response. 2.43e+07. In the year 2010, what is the difference between the Net Disbursements (current US$) in Least developed countries and Net Disbursements (current US$) in Ecuador?
Provide a succinct answer. 2.44e+07. In the year 2010, what is the difference between the Net Disbursements (current US$) in Least developed countries and Net Disbursements (current US$) in Yemen, Rep.?
Ensure brevity in your answer.  2.35e+07. In the year 2010, what is the difference between the Net Disbursements (current US$) of Cambodia and Net Disbursements (current US$) of Yemen, Rep.?
Offer a very short reply. -8.00e+05. In the year 2010, what is the difference between the Net Disbursements (current US$) in Ecuador and Net Disbursements (current US$) in Yemen, Rep.?
Your response must be concise. -9.20e+05. In the year 2011, what is the difference between the Net Disbursements (current US$) in Least developed countries and Net Disbursements (current US$) in Cambodia?
Give a very brief answer. 2.03e+07. In the year 2011, what is the difference between the Net Disbursements (current US$) of Least developed countries and Net Disbursements (current US$) of Ecuador?
Your answer should be very brief. 2.11e+07. In the year 2011, what is the difference between the Net Disbursements (current US$) of Least developed countries and Net Disbursements (current US$) of Yemen, Rep.?
Provide a short and direct response. 2.09e+07. In the year 2011, what is the difference between the Net Disbursements (current US$) of Cambodia and Net Disbursements (current US$) of Ecuador?
Provide a succinct answer. 8.70e+05. In the year 2011, what is the difference between the Net Disbursements (current US$) in Cambodia and Net Disbursements (current US$) in Yemen, Rep.?
Provide a short and direct response. 6.50e+05. In the year 2011, what is the difference between the Net Disbursements (current US$) of Ecuador and Net Disbursements (current US$) of Yemen, Rep.?
Your answer should be very brief. -2.20e+05. In the year 2012, what is the difference between the Net Disbursements (current US$) of Least developed countries and Net Disbursements (current US$) of Cambodia?
Ensure brevity in your answer.  2.04e+07. In the year 2012, what is the difference between the Net Disbursements (current US$) of Least developed countries and Net Disbursements (current US$) of Ecuador?
Offer a terse response. 2.13e+07. In the year 2012, what is the difference between the Net Disbursements (current US$) in Least developed countries and Net Disbursements (current US$) in Yemen, Rep.?
Your answer should be compact. 2.08e+07. In the year 2012, what is the difference between the Net Disbursements (current US$) in Cambodia and Net Disbursements (current US$) in Ecuador?
Keep it short and to the point. 8.80e+05. In the year 2012, what is the difference between the Net Disbursements (current US$) of Cambodia and Net Disbursements (current US$) of Yemen, Rep.?
Your response must be concise. 4.50e+05. In the year 2012, what is the difference between the Net Disbursements (current US$) of Ecuador and Net Disbursements (current US$) of Yemen, Rep.?
Ensure brevity in your answer.  -4.30e+05. In the year 2013, what is the difference between the Net Disbursements (current US$) of Least developed countries and Net Disbursements (current US$) of Cambodia?
Offer a very short reply. 1.10e+07. In the year 2013, what is the difference between the Net Disbursements (current US$) in Least developed countries and Net Disbursements (current US$) in Ecuador?
Offer a very short reply. 1.20e+07. In the year 2013, what is the difference between the Net Disbursements (current US$) of Least developed countries and Net Disbursements (current US$) of Yemen, Rep.?
Keep it short and to the point. 1.15e+07. In the year 2013, what is the difference between the Net Disbursements (current US$) in Cambodia and Net Disbursements (current US$) in Ecuador?
Ensure brevity in your answer.  1.09e+06. In the year 2013, what is the difference between the Net Disbursements (current US$) of Ecuador and Net Disbursements (current US$) of Yemen, Rep.?
Offer a terse response. -5.40e+05. What is the ratio of the Net Disbursements (current US$) of Least developed countries in 2006 to that in 2007?
Your answer should be very brief. 0.56. What is the ratio of the Net Disbursements (current US$) in Yemen, Rep. in 2006 to that in 2007?
Make the answer very short. 0.68. What is the ratio of the Net Disbursements (current US$) of Least developed countries in 2006 to that in 2008?
Provide a short and direct response. 0.19. What is the ratio of the Net Disbursements (current US$) of Cambodia in 2006 to that in 2008?
Keep it short and to the point. 1.72. What is the ratio of the Net Disbursements (current US$) of Ecuador in 2006 to that in 2008?
Offer a very short reply. 0.55. What is the ratio of the Net Disbursements (current US$) of Yemen, Rep. in 2006 to that in 2008?
Provide a succinct answer. 0.67. What is the ratio of the Net Disbursements (current US$) of Least developed countries in 2006 to that in 2009?
Give a very brief answer. 0.25. What is the ratio of the Net Disbursements (current US$) in Cambodia in 2006 to that in 2009?
Provide a short and direct response. 0.11. What is the ratio of the Net Disbursements (current US$) of Ecuador in 2006 to that in 2009?
Your answer should be very brief. 0.58. What is the ratio of the Net Disbursements (current US$) of Yemen, Rep. in 2006 to that in 2009?
Ensure brevity in your answer.  0.66. What is the ratio of the Net Disbursements (current US$) of Least developed countries in 2006 to that in 2010?
Your answer should be compact. 0.41. What is the ratio of the Net Disbursements (current US$) of Cambodia in 2006 to that in 2010?
Offer a very short reply. 1.55. What is the ratio of the Net Disbursements (current US$) of Ecuador in 2006 to that in 2010?
Your answer should be very brief. 1.38. What is the ratio of the Net Disbursements (current US$) of Yemen, Rep. in 2006 to that in 2010?
Offer a very short reply. 0.92. What is the ratio of the Net Disbursements (current US$) in Least developed countries in 2006 to that in 2011?
Make the answer very short. 0.47. What is the ratio of the Net Disbursements (current US$) of Cambodia in 2006 to that in 2011?
Keep it short and to the point. 0.32. What is the ratio of the Net Disbursements (current US$) of Ecuador in 2006 to that in 2011?
Your answer should be compact. 1.22. What is the ratio of the Net Disbursements (current US$) in Yemen, Rep. in 2006 to that in 2011?
Provide a succinct answer. 2.97. What is the ratio of the Net Disbursements (current US$) in Least developed countries in 2006 to that in 2012?
Ensure brevity in your answer.  0.47. What is the ratio of the Net Disbursements (current US$) of Cambodia in 2006 to that in 2012?
Provide a short and direct response. 0.33. What is the ratio of the Net Disbursements (current US$) of Yemen, Rep. in 2006 to that in 2012?
Your answer should be compact. 1.92. What is the ratio of the Net Disbursements (current US$) in Least developed countries in 2006 to that in 2013?
Give a very brief answer. 0.82. What is the ratio of the Net Disbursements (current US$) of Cambodia in 2006 to that in 2013?
Provide a short and direct response. 0.27. What is the ratio of the Net Disbursements (current US$) of Ecuador in 2006 to that in 2013?
Provide a succinct answer. 1.57. What is the ratio of the Net Disbursements (current US$) in Yemen, Rep. in 2006 to that in 2013?
Offer a terse response. 1.51. What is the ratio of the Net Disbursements (current US$) in Least developed countries in 2007 to that in 2008?
Offer a very short reply. 0.34. What is the ratio of the Net Disbursements (current US$) of Cambodia in 2007 to that in 2008?
Your answer should be compact. 0.56. What is the ratio of the Net Disbursements (current US$) in Yemen, Rep. in 2007 to that in 2008?
Your response must be concise. 0.99. What is the ratio of the Net Disbursements (current US$) of Least developed countries in 2007 to that in 2009?
Give a very brief answer. 0.45. What is the ratio of the Net Disbursements (current US$) in Cambodia in 2007 to that in 2009?
Your response must be concise. 0.04. What is the ratio of the Net Disbursements (current US$) in Ecuador in 2007 to that in 2009?
Make the answer very short. 0.63. What is the ratio of the Net Disbursements (current US$) in Yemen, Rep. in 2007 to that in 2009?
Give a very brief answer. 0.98. What is the ratio of the Net Disbursements (current US$) in Least developed countries in 2007 to that in 2010?
Give a very brief answer. 0.72. What is the ratio of the Net Disbursements (current US$) of Cambodia in 2007 to that in 2010?
Your answer should be compact. 0.5. What is the ratio of the Net Disbursements (current US$) of Yemen, Rep. in 2007 to that in 2010?
Provide a short and direct response. 1.36. What is the ratio of the Net Disbursements (current US$) of Least developed countries in 2007 to that in 2011?
Offer a terse response. 0.83. What is the ratio of the Net Disbursements (current US$) in Cambodia in 2007 to that in 2011?
Make the answer very short. 0.1. What is the ratio of the Net Disbursements (current US$) in Yemen, Rep. in 2007 to that in 2011?
Your answer should be very brief. 4.39. What is the ratio of the Net Disbursements (current US$) in Least developed countries in 2007 to that in 2012?
Your answer should be very brief. 0.82. What is the ratio of the Net Disbursements (current US$) of Cambodia in 2007 to that in 2012?
Provide a short and direct response. 0.11. What is the ratio of the Net Disbursements (current US$) of Ecuador in 2007 to that in 2012?
Your answer should be compact. 2.4. What is the ratio of the Net Disbursements (current US$) of Yemen, Rep. in 2007 to that in 2012?
Your response must be concise. 2.83. What is the ratio of the Net Disbursements (current US$) in Least developed countries in 2007 to that in 2013?
Offer a terse response. 1.45. What is the ratio of the Net Disbursements (current US$) of Cambodia in 2007 to that in 2013?
Your answer should be very brief. 0.09. What is the ratio of the Net Disbursements (current US$) of Ecuador in 2007 to that in 2013?
Your answer should be very brief. 1.71. What is the ratio of the Net Disbursements (current US$) in Yemen, Rep. in 2007 to that in 2013?
Offer a very short reply. 2.23. What is the ratio of the Net Disbursements (current US$) of Least developed countries in 2008 to that in 2009?
Your response must be concise. 1.34. What is the ratio of the Net Disbursements (current US$) in Cambodia in 2008 to that in 2009?
Your answer should be very brief. 0.07. What is the ratio of the Net Disbursements (current US$) in Ecuador in 2008 to that in 2009?
Give a very brief answer. 1.05. What is the ratio of the Net Disbursements (current US$) in Yemen, Rep. in 2008 to that in 2009?
Your answer should be compact. 0.99. What is the ratio of the Net Disbursements (current US$) of Least developed countries in 2008 to that in 2010?
Your answer should be very brief. 2.14. What is the ratio of the Net Disbursements (current US$) in Yemen, Rep. in 2008 to that in 2010?
Offer a terse response. 1.38. What is the ratio of the Net Disbursements (current US$) of Least developed countries in 2008 to that in 2011?
Make the answer very short. 2.47. What is the ratio of the Net Disbursements (current US$) of Cambodia in 2008 to that in 2011?
Ensure brevity in your answer.  0.19. What is the ratio of the Net Disbursements (current US$) of Ecuador in 2008 to that in 2011?
Make the answer very short. 2.22. What is the ratio of the Net Disbursements (current US$) in Yemen, Rep. in 2008 to that in 2011?
Your answer should be compact. 4.45. What is the ratio of the Net Disbursements (current US$) of Least developed countries in 2008 to that in 2012?
Ensure brevity in your answer.  2.46. What is the ratio of the Net Disbursements (current US$) in Cambodia in 2008 to that in 2012?
Keep it short and to the point. 0.19. What is the ratio of the Net Disbursements (current US$) in Yemen, Rep. in 2008 to that in 2012?
Your answer should be compact. 2.88. What is the ratio of the Net Disbursements (current US$) of Least developed countries in 2008 to that in 2013?
Your answer should be very brief. 4.33. What is the ratio of the Net Disbursements (current US$) in Cambodia in 2008 to that in 2013?
Keep it short and to the point. 0.16. What is the ratio of the Net Disbursements (current US$) of Ecuador in 2008 to that in 2013?
Your answer should be compact. 2.86. What is the ratio of the Net Disbursements (current US$) in Yemen, Rep. in 2008 to that in 2013?
Offer a terse response. 2.26. What is the ratio of the Net Disbursements (current US$) in Least developed countries in 2009 to that in 2010?
Ensure brevity in your answer.  1.6. What is the ratio of the Net Disbursements (current US$) of Ecuador in 2009 to that in 2010?
Give a very brief answer. 2.38. What is the ratio of the Net Disbursements (current US$) of Yemen, Rep. in 2009 to that in 2010?
Provide a succinct answer. 1.39. What is the ratio of the Net Disbursements (current US$) in Least developed countries in 2009 to that in 2011?
Give a very brief answer. 1.85. What is the ratio of the Net Disbursements (current US$) in Cambodia in 2009 to that in 2011?
Ensure brevity in your answer.  2.88. What is the ratio of the Net Disbursements (current US$) of Ecuador in 2009 to that in 2011?
Keep it short and to the point. 2.11. What is the ratio of the Net Disbursements (current US$) in Yemen, Rep. in 2009 to that in 2011?
Keep it short and to the point. 4.48. What is the ratio of the Net Disbursements (current US$) in Least developed countries in 2009 to that in 2012?
Provide a short and direct response. 1.84. What is the ratio of the Net Disbursements (current US$) of Cambodia in 2009 to that in 2012?
Make the answer very short. 2.97. What is the ratio of the Net Disbursements (current US$) of Yemen, Rep. in 2009 to that in 2012?
Your answer should be very brief. 2.9. What is the ratio of the Net Disbursements (current US$) of Least developed countries in 2009 to that in 2013?
Keep it short and to the point. 3.24. What is the ratio of the Net Disbursements (current US$) of Cambodia in 2009 to that in 2013?
Offer a terse response. 2.38. What is the ratio of the Net Disbursements (current US$) of Ecuador in 2009 to that in 2013?
Make the answer very short. 2.71. What is the ratio of the Net Disbursements (current US$) of Yemen, Rep. in 2009 to that in 2013?
Your answer should be very brief. 2.28. What is the ratio of the Net Disbursements (current US$) of Least developed countries in 2010 to that in 2011?
Your answer should be compact. 1.15. What is the ratio of the Net Disbursements (current US$) in Cambodia in 2010 to that in 2011?
Your answer should be very brief. 0.21. What is the ratio of the Net Disbursements (current US$) of Yemen, Rep. in 2010 to that in 2011?
Make the answer very short. 3.23. What is the ratio of the Net Disbursements (current US$) of Least developed countries in 2010 to that in 2012?
Ensure brevity in your answer.  1.15. What is the ratio of the Net Disbursements (current US$) of Cambodia in 2010 to that in 2012?
Give a very brief answer. 0.22. What is the ratio of the Net Disbursements (current US$) of Yemen, Rep. in 2010 to that in 2012?
Your answer should be compact. 2.08. What is the ratio of the Net Disbursements (current US$) of Least developed countries in 2010 to that in 2013?
Ensure brevity in your answer.  2.02. What is the ratio of the Net Disbursements (current US$) of Cambodia in 2010 to that in 2013?
Make the answer very short. 0.17. What is the ratio of the Net Disbursements (current US$) in Yemen, Rep. in 2010 to that in 2013?
Ensure brevity in your answer.  1.64. What is the ratio of the Net Disbursements (current US$) of Least developed countries in 2011 to that in 2012?
Provide a succinct answer. 0.99. What is the ratio of the Net Disbursements (current US$) in Cambodia in 2011 to that in 2012?
Ensure brevity in your answer.  1.03. What is the ratio of the Net Disbursements (current US$) of Ecuador in 2011 to that in 2012?
Ensure brevity in your answer.  1.8. What is the ratio of the Net Disbursements (current US$) of Yemen, Rep. in 2011 to that in 2012?
Make the answer very short. 0.65. What is the ratio of the Net Disbursements (current US$) of Least developed countries in 2011 to that in 2013?
Ensure brevity in your answer.  1.75. What is the ratio of the Net Disbursements (current US$) in Cambodia in 2011 to that in 2013?
Provide a short and direct response. 0.83. What is the ratio of the Net Disbursements (current US$) in Yemen, Rep. in 2011 to that in 2013?
Make the answer very short. 0.51. What is the ratio of the Net Disbursements (current US$) of Least developed countries in 2012 to that in 2013?
Your answer should be very brief. 1.76. What is the ratio of the Net Disbursements (current US$) of Cambodia in 2012 to that in 2013?
Your response must be concise. 0.8. What is the ratio of the Net Disbursements (current US$) in Ecuador in 2012 to that in 2013?
Your answer should be very brief. 0.71. What is the ratio of the Net Disbursements (current US$) in Yemen, Rep. in 2012 to that in 2013?
Your answer should be compact. 0.79. What is the difference between the highest and the second highest Net Disbursements (current US$) in Least developed countries?
Keep it short and to the point. 1.32e+07. What is the difference between the highest and the second highest Net Disbursements (current US$) of Cambodia?
Your answer should be compact. 1.60e+06. What is the difference between the highest and the lowest Net Disbursements (current US$) of Least developed countries?
Give a very brief answer. 4.25e+07. What is the difference between the highest and the lowest Net Disbursements (current US$) in Cambodia?
Keep it short and to the point. 2.66e+06. What is the difference between the highest and the lowest Net Disbursements (current US$) in Ecuador?
Your answer should be very brief. 1.50e+05. What is the difference between the highest and the lowest Net Disbursements (current US$) in Yemen, Rep.?
Offer a terse response. 1.08e+06. 